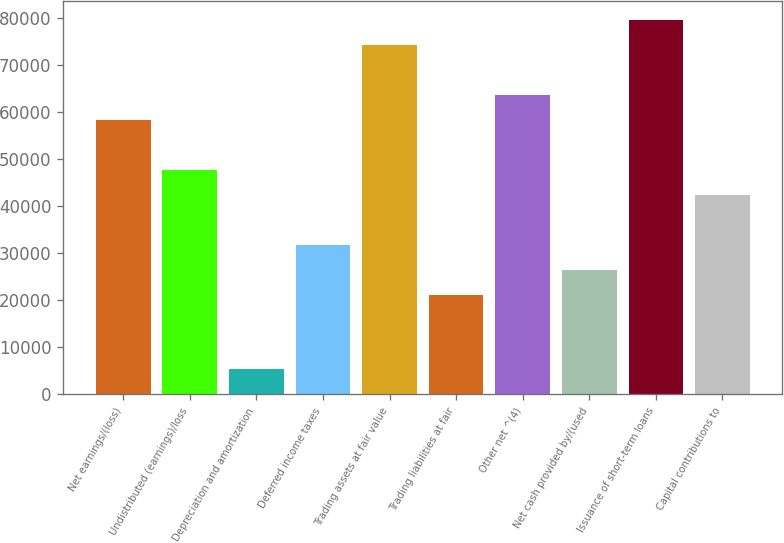Convert chart. <chart><loc_0><loc_0><loc_500><loc_500><bar_chart><fcel>Net earnings/(loss)<fcel>Undistributed (earnings)/loss<fcel>Depreciation and amortization<fcel>Deferred income taxes<fcel>Trading assets at fair value<fcel>Trading liabilities at fair<fcel>Other net ^(4)<fcel>Net cash provided by/(used<fcel>Issuance of short-term loans<fcel>Capital contributions to<nl><fcel>58344.6<fcel>47737.4<fcel>5308.6<fcel>31826.6<fcel>74255.4<fcel>21219.4<fcel>63648.2<fcel>26523<fcel>79559<fcel>42433.8<nl></chart> 